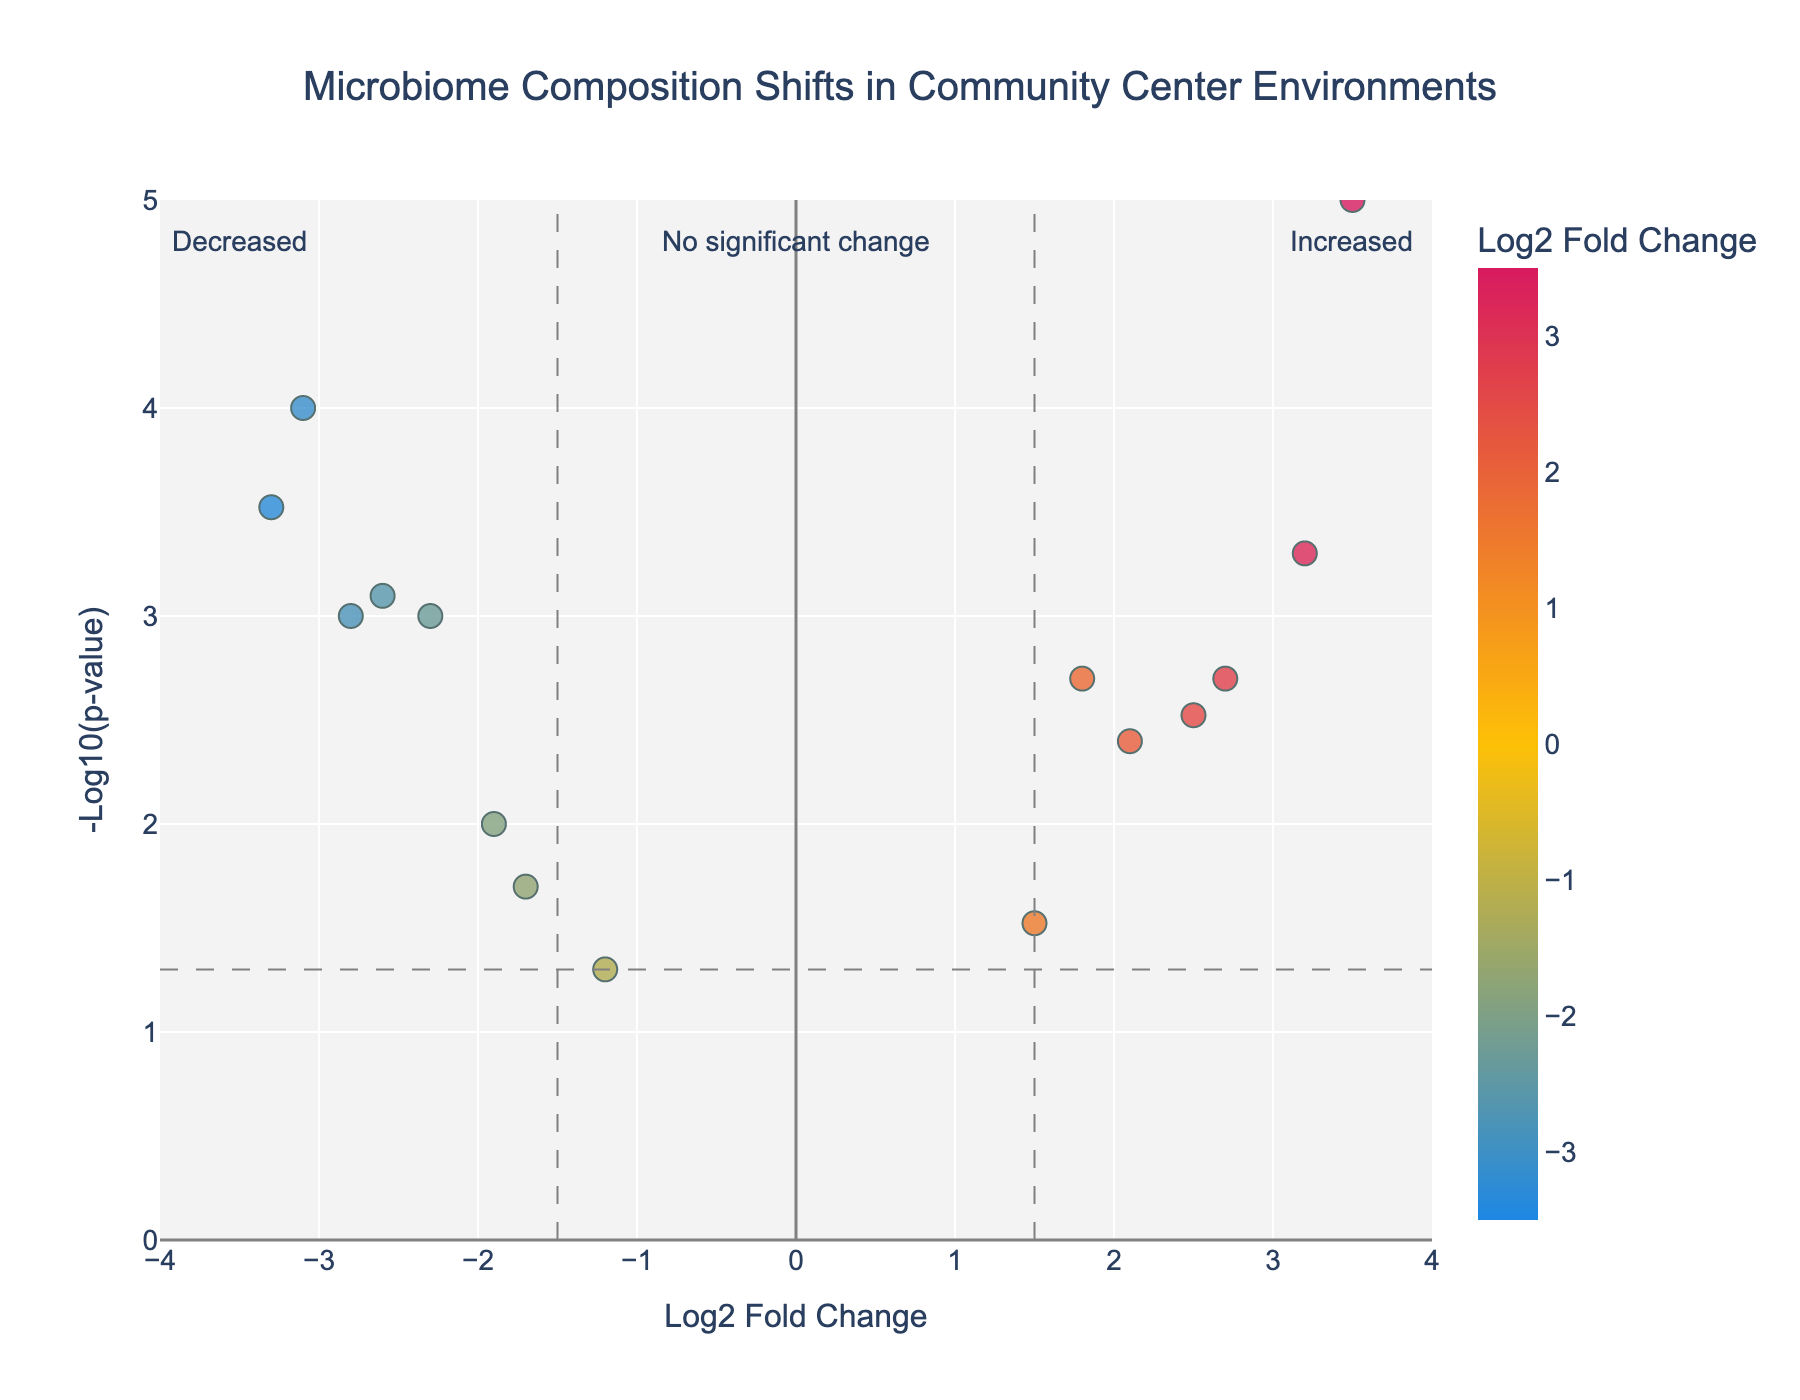What's the title of the plot? The plot's title is usually displayed at the top of the figure.
Answer: Microbiome Composition Shifts in Community Center Environments What does the x-axis represent? The x-axis usually represents a variable mentioned along the axis line.
Answer: Log2 Fold Change How many microorganisms have a Log2 Fold Change greater than 1.5? By looking at the positive side of the x-axis and counting the relevant data points.
Answer: 5 Which microorganism shows the most significant increase in abundance? Look for the data point on the positive side of the x-axis with the highest -log10(p-value) and log2 Fold Change.
Answer: Rhodococcus erythropolis Which two microorganisms have p-values closest to 0.002? Check the data points and compare the p-values to find those nearest to 0.002.
Answer: Bacillus subtilis and Micrococcus luteus How many microorganisms are significantly decreased with p-values less than 0.05? Count the data points on the negative side of the x-axis, below the p-value threshold line.
Answer: 7 What does the color variation in the plot indicate? The color scale usually represents the intensity or other attribute of the data, explained in the legend or plot description.
Answer: The log2 Fold Change of the microorganisms Which microorganism has the least significant p-value while being increased in abundance? Locate the data point on the positive side of the x-axis closest to the p-value threshold line.
Answer: Streptococcus salivarius What threshold values are used to determine significance in fold change and p-value? The thresholds are typically marked by lines or annotations on the plot.
Answer: Fold change = 1.5, p-value = 0.05 What are the three annotations at the top of the plot indicating? Annotations provide supplementary information and are usually displayed as text.
Answer: Increased, Decreased, No significant change 